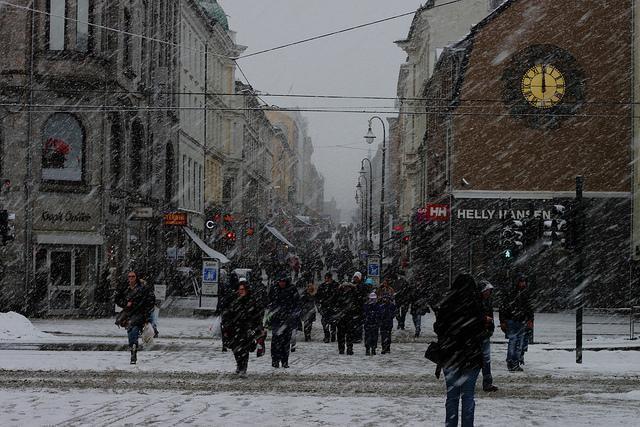What is the composition of the falling material?
Choose the right answer from the provided options to respond to the question.
Options: Stone, brick, cloth, water. Water. 